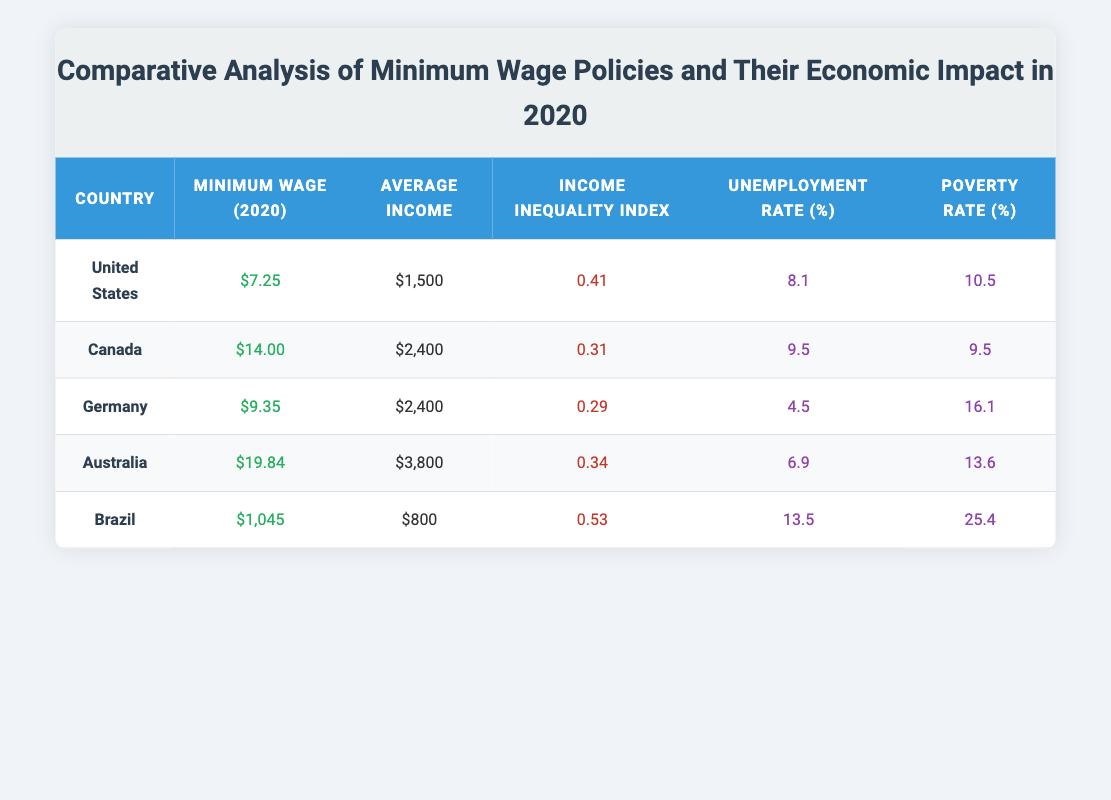What is the minimum wage in Canada for 2020? The table states the minimum wage for Canada in 2020 is $14.00.
Answer: $14.00 Which country has the highest unemployment rate in 2020? Referring to the unemployment rate column, Brazil has the highest unemployment rate listed at 13.5%.
Answer: Brazil What is the average income for Australia? According to the table, the average income for Australia is $3,800.
Answer: $3,800 What is the total minimum wage for all countries combined? Adding the minimum wages together: $7.25 + $14.00 + $9.35 + $19.84 + $1,045 = $1,095.44.
Answer: $1,095.44 Is the income inequality index higher in the United States than in Canada? The income inequality index for the United States is 0.41, while for Canada it is 0.31. Since 0.41 is greater than 0.31, the statement is true.
Answer: Yes What is the average poverty rate for the countries listed? To find the average poverty rate: (10.5 + 9.5 + 16.1 + 13.6 + 25.4) / 5 = 15.42. Therefore, the average poverty rate is 15.42%.
Answer: 15.42 Which country has both the highest poverty rate and income inequality index? Looking at both columns, Brazil has the highest poverty rate at 25.4% and the highest income inequality index at 0.53.
Answer: Brazil In which country is the unemployment rate lower than the average income? By comparing the unemployment rates with average incomes: Unemployment rates for the United States (8.1), Canada (9.5), Brazil (13.5) are higher than their respective average incomes. Only Germany (4.5) has an unemployment rate lower than its average income of $2,400.
Answer: Germany What is the difference between the average income of the highest and lowest countries? The highest average income is Australia at $3,800, and the lowest is Brazil at $800. The difference is $3,800 - $800 = $3,000.
Answer: $3,000 